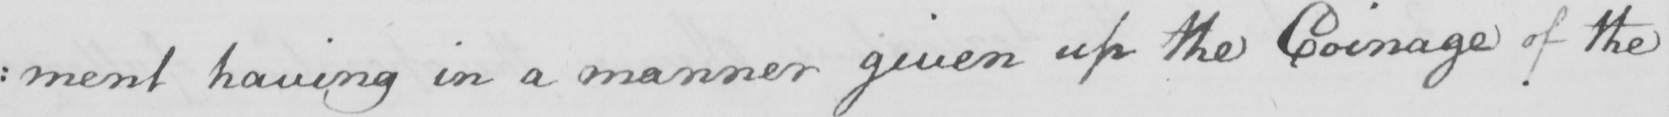What is written in this line of handwriting? : ment having in a manner given up the Coinage of the 